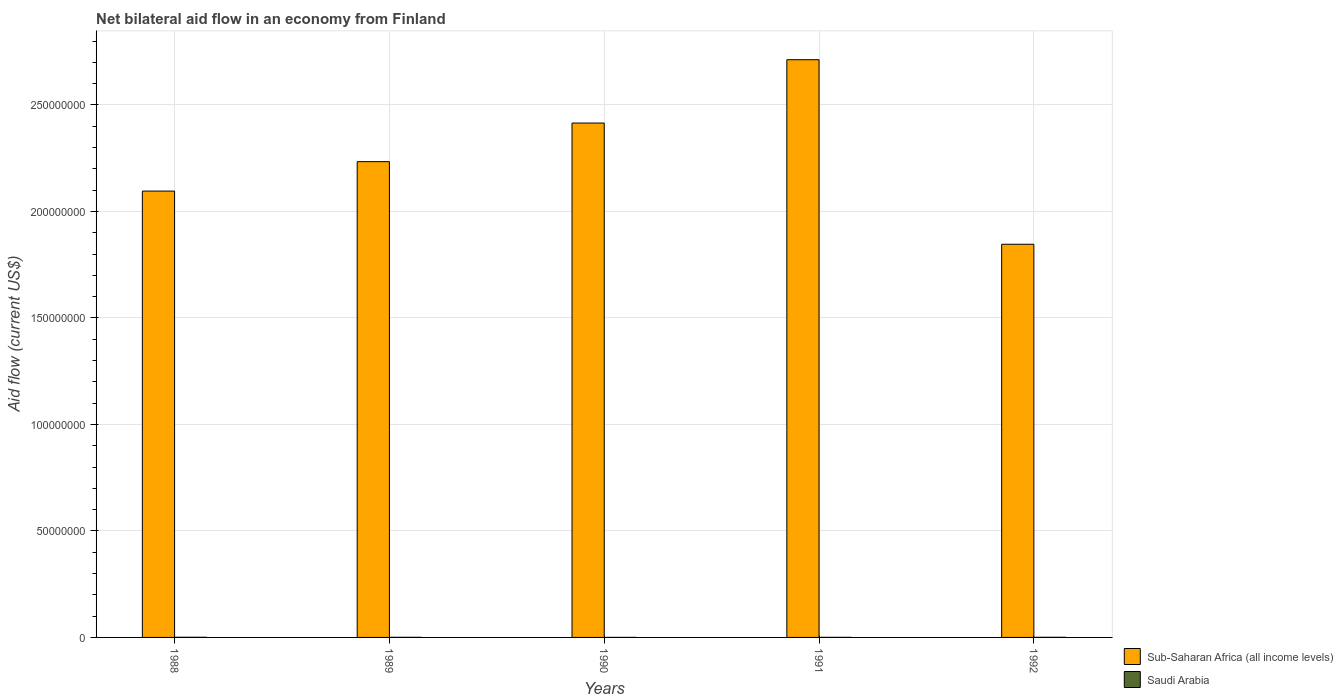How many different coloured bars are there?
Offer a terse response. 2. How many groups of bars are there?
Provide a succinct answer. 5. Are the number of bars on each tick of the X-axis equal?
Provide a short and direct response. Yes. How many bars are there on the 3rd tick from the left?
Your response must be concise. 2. How many bars are there on the 2nd tick from the right?
Keep it short and to the point. 2. What is the label of the 4th group of bars from the left?
Provide a succinct answer. 1991. In how many cases, is the number of bars for a given year not equal to the number of legend labels?
Your answer should be compact. 0. What is the net bilateral aid flow in Sub-Saharan Africa (all income levels) in 1988?
Offer a very short reply. 2.10e+08. Across all years, what is the maximum net bilateral aid flow in Sub-Saharan Africa (all income levels)?
Make the answer very short. 2.71e+08. Across all years, what is the minimum net bilateral aid flow in Sub-Saharan Africa (all income levels)?
Provide a succinct answer. 1.85e+08. What is the total net bilateral aid flow in Saudi Arabia in the graph?
Offer a terse response. 2.40e+05. What is the difference between the net bilateral aid flow in Sub-Saharan Africa (all income levels) in 1988 and that in 1990?
Your answer should be compact. -3.20e+07. What is the difference between the net bilateral aid flow in Saudi Arabia in 1991 and the net bilateral aid flow in Sub-Saharan Africa (all income levels) in 1990?
Your answer should be very brief. -2.41e+08. What is the average net bilateral aid flow in Sub-Saharan Africa (all income levels) per year?
Give a very brief answer. 2.26e+08. In the year 1992, what is the difference between the net bilateral aid flow in Saudi Arabia and net bilateral aid flow in Sub-Saharan Africa (all income levels)?
Give a very brief answer. -1.85e+08. In how many years, is the net bilateral aid flow in Saudi Arabia greater than 240000000 US$?
Make the answer very short. 0. What is the ratio of the net bilateral aid flow in Saudi Arabia in 1989 to that in 1992?
Your answer should be compact. 0.83. What is the difference between the highest and the second highest net bilateral aid flow in Sub-Saharan Africa (all income levels)?
Provide a succinct answer. 2.97e+07. In how many years, is the net bilateral aid flow in Sub-Saharan Africa (all income levels) greater than the average net bilateral aid flow in Sub-Saharan Africa (all income levels) taken over all years?
Give a very brief answer. 2. Is the sum of the net bilateral aid flow in Saudi Arabia in 1989 and 1990 greater than the maximum net bilateral aid flow in Sub-Saharan Africa (all income levels) across all years?
Your response must be concise. No. What does the 1st bar from the left in 1992 represents?
Your response must be concise. Sub-Saharan Africa (all income levels). What does the 2nd bar from the right in 1992 represents?
Keep it short and to the point. Sub-Saharan Africa (all income levels). How many years are there in the graph?
Offer a terse response. 5. What is the difference between two consecutive major ticks on the Y-axis?
Ensure brevity in your answer.  5.00e+07. Are the values on the major ticks of Y-axis written in scientific E-notation?
Your response must be concise. No. Does the graph contain any zero values?
Provide a short and direct response. No. Does the graph contain grids?
Make the answer very short. Yes. How many legend labels are there?
Your response must be concise. 2. How are the legend labels stacked?
Your answer should be very brief. Vertical. What is the title of the graph?
Your answer should be very brief. Net bilateral aid flow in an economy from Finland. Does "Least developed countries" appear as one of the legend labels in the graph?
Offer a terse response. No. What is the label or title of the X-axis?
Your response must be concise. Years. What is the Aid flow (current US$) of Sub-Saharan Africa (all income levels) in 1988?
Ensure brevity in your answer.  2.10e+08. What is the Aid flow (current US$) of Saudi Arabia in 1988?
Offer a terse response. 7.00e+04. What is the Aid flow (current US$) of Sub-Saharan Africa (all income levels) in 1989?
Provide a succinct answer. 2.23e+08. What is the Aid flow (current US$) of Saudi Arabia in 1989?
Your response must be concise. 5.00e+04. What is the Aid flow (current US$) in Sub-Saharan Africa (all income levels) in 1990?
Keep it short and to the point. 2.41e+08. What is the Aid flow (current US$) of Saudi Arabia in 1990?
Give a very brief answer. 2.00e+04. What is the Aid flow (current US$) in Sub-Saharan Africa (all income levels) in 1991?
Your response must be concise. 2.71e+08. What is the Aid flow (current US$) of Saudi Arabia in 1991?
Offer a very short reply. 4.00e+04. What is the Aid flow (current US$) in Sub-Saharan Africa (all income levels) in 1992?
Ensure brevity in your answer.  1.85e+08. What is the Aid flow (current US$) of Saudi Arabia in 1992?
Keep it short and to the point. 6.00e+04. Across all years, what is the maximum Aid flow (current US$) of Sub-Saharan Africa (all income levels)?
Offer a very short reply. 2.71e+08. Across all years, what is the minimum Aid flow (current US$) in Sub-Saharan Africa (all income levels)?
Ensure brevity in your answer.  1.85e+08. Across all years, what is the minimum Aid flow (current US$) in Saudi Arabia?
Give a very brief answer. 2.00e+04. What is the total Aid flow (current US$) in Sub-Saharan Africa (all income levels) in the graph?
Your answer should be very brief. 1.13e+09. What is the total Aid flow (current US$) of Saudi Arabia in the graph?
Your answer should be very brief. 2.40e+05. What is the difference between the Aid flow (current US$) in Sub-Saharan Africa (all income levels) in 1988 and that in 1989?
Your response must be concise. -1.38e+07. What is the difference between the Aid flow (current US$) of Saudi Arabia in 1988 and that in 1989?
Your response must be concise. 2.00e+04. What is the difference between the Aid flow (current US$) of Sub-Saharan Africa (all income levels) in 1988 and that in 1990?
Provide a short and direct response. -3.20e+07. What is the difference between the Aid flow (current US$) in Sub-Saharan Africa (all income levels) in 1988 and that in 1991?
Keep it short and to the point. -6.17e+07. What is the difference between the Aid flow (current US$) in Sub-Saharan Africa (all income levels) in 1988 and that in 1992?
Your answer should be very brief. 2.50e+07. What is the difference between the Aid flow (current US$) of Saudi Arabia in 1988 and that in 1992?
Offer a very short reply. 10000. What is the difference between the Aid flow (current US$) in Sub-Saharan Africa (all income levels) in 1989 and that in 1990?
Offer a very short reply. -1.81e+07. What is the difference between the Aid flow (current US$) of Saudi Arabia in 1989 and that in 1990?
Offer a very short reply. 3.00e+04. What is the difference between the Aid flow (current US$) of Sub-Saharan Africa (all income levels) in 1989 and that in 1991?
Ensure brevity in your answer.  -4.79e+07. What is the difference between the Aid flow (current US$) in Saudi Arabia in 1989 and that in 1991?
Your answer should be very brief. 10000. What is the difference between the Aid flow (current US$) of Sub-Saharan Africa (all income levels) in 1989 and that in 1992?
Ensure brevity in your answer.  3.88e+07. What is the difference between the Aid flow (current US$) in Sub-Saharan Africa (all income levels) in 1990 and that in 1991?
Offer a terse response. -2.97e+07. What is the difference between the Aid flow (current US$) of Sub-Saharan Africa (all income levels) in 1990 and that in 1992?
Keep it short and to the point. 5.69e+07. What is the difference between the Aid flow (current US$) in Sub-Saharan Africa (all income levels) in 1991 and that in 1992?
Provide a short and direct response. 8.66e+07. What is the difference between the Aid flow (current US$) of Saudi Arabia in 1991 and that in 1992?
Your response must be concise. -2.00e+04. What is the difference between the Aid flow (current US$) of Sub-Saharan Africa (all income levels) in 1988 and the Aid flow (current US$) of Saudi Arabia in 1989?
Ensure brevity in your answer.  2.09e+08. What is the difference between the Aid flow (current US$) of Sub-Saharan Africa (all income levels) in 1988 and the Aid flow (current US$) of Saudi Arabia in 1990?
Your response must be concise. 2.10e+08. What is the difference between the Aid flow (current US$) in Sub-Saharan Africa (all income levels) in 1988 and the Aid flow (current US$) in Saudi Arabia in 1991?
Make the answer very short. 2.10e+08. What is the difference between the Aid flow (current US$) of Sub-Saharan Africa (all income levels) in 1988 and the Aid flow (current US$) of Saudi Arabia in 1992?
Make the answer very short. 2.09e+08. What is the difference between the Aid flow (current US$) in Sub-Saharan Africa (all income levels) in 1989 and the Aid flow (current US$) in Saudi Arabia in 1990?
Keep it short and to the point. 2.23e+08. What is the difference between the Aid flow (current US$) in Sub-Saharan Africa (all income levels) in 1989 and the Aid flow (current US$) in Saudi Arabia in 1991?
Your answer should be very brief. 2.23e+08. What is the difference between the Aid flow (current US$) of Sub-Saharan Africa (all income levels) in 1989 and the Aid flow (current US$) of Saudi Arabia in 1992?
Your answer should be very brief. 2.23e+08. What is the difference between the Aid flow (current US$) of Sub-Saharan Africa (all income levels) in 1990 and the Aid flow (current US$) of Saudi Arabia in 1991?
Your response must be concise. 2.41e+08. What is the difference between the Aid flow (current US$) of Sub-Saharan Africa (all income levels) in 1990 and the Aid flow (current US$) of Saudi Arabia in 1992?
Your answer should be compact. 2.41e+08. What is the difference between the Aid flow (current US$) in Sub-Saharan Africa (all income levels) in 1991 and the Aid flow (current US$) in Saudi Arabia in 1992?
Provide a short and direct response. 2.71e+08. What is the average Aid flow (current US$) in Sub-Saharan Africa (all income levels) per year?
Your response must be concise. 2.26e+08. What is the average Aid flow (current US$) in Saudi Arabia per year?
Your answer should be very brief. 4.80e+04. In the year 1988, what is the difference between the Aid flow (current US$) in Sub-Saharan Africa (all income levels) and Aid flow (current US$) in Saudi Arabia?
Your response must be concise. 2.09e+08. In the year 1989, what is the difference between the Aid flow (current US$) in Sub-Saharan Africa (all income levels) and Aid flow (current US$) in Saudi Arabia?
Your answer should be compact. 2.23e+08. In the year 1990, what is the difference between the Aid flow (current US$) of Sub-Saharan Africa (all income levels) and Aid flow (current US$) of Saudi Arabia?
Keep it short and to the point. 2.41e+08. In the year 1991, what is the difference between the Aid flow (current US$) of Sub-Saharan Africa (all income levels) and Aid flow (current US$) of Saudi Arabia?
Ensure brevity in your answer.  2.71e+08. In the year 1992, what is the difference between the Aid flow (current US$) of Sub-Saharan Africa (all income levels) and Aid flow (current US$) of Saudi Arabia?
Your response must be concise. 1.85e+08. What is the ratio of the Aid flow (current US$) of Sub-Saharan Africa (all income levels) in 1988 to that in 1989?
Ensure brevity in your answer.  0.94. What is the ratio of the Aid flow (current US$) of Saudi Arabia in 1988 to that in 1989?
Your answer should be very brief. 1.4. What is the ratio of the Aid flow (current US$) of Sub-Saharan Africa (all income levels) in 1988 to that in 1990?
Provide a short and direct response. 0.87. What is the ratio of the Aid flow (current US$) of Saudi Arabia in 1988 to that in 1990?
Offer a terse response. 3.5. What is the ratio of the Aid flow (current US$) of Sub-Saharan Africa (all income levels) in 1988 to that in 1991?
Offer a terse response. 0.77. What is the ratio of the Aid flow (current US$) in Sub-Saharan Africa (all income levels) in 1988 to that in 1992?
Give a very brief answer. 1.14. What is the ratio of the Aid flow (current US$) in Saudi Arabia in 1988 to that in 1992?
Offer a terse response. 1.17. What is the ratio of the Aid flow (current US$) of Sub-Saharan Africa (all income levels) in 1989 to that in 1990?
Provide a short and direct response. 0.92. What is the ratio of the Aid flow (current US$) of Saudi Arabia in 1989 to that in 1990?
Offer a very short reply. 2.5. What is the ratio of the Aid flow (current US$) of Sub-Saharan Africa (all income levels) in 1989 to that in 1991?
Provide a succinct answer. 0.82. What is the ratio of the Aid flow (current US$) of Saudi Arabia in 1989 to that in 1991?
Provide a short and direct response. 1.25. What is the ratio of the Aid flow (current US$) of Sub-Saharan Africa (all income levels) in 1989 to that in 1992?
Your response must be concise. 1.21. What is the ratio of the Aid flow (current US$) of Saudi Arabia in 1989 to that in 1992?
Ensure brevity in your answer.  0.83. What is the ratio of the Aid flow (current US$) in Sub-Saharan Africa (all income levels) in 1990 to that in 1991?
Offer a terse response. 0.89. What is the ratio of the Aid flow (current US$) of Saudi Arabia in 1990 to that in 1991?
Provide a succinct answer. 0.5. What is the ratio of the Aid flow (current US$) in Sub-Saharan Africa (all income levels) in 1990 to that in 1992?
Your response must be concise. 1.31. What is the ratio of the Aid flow (current US$) of Sub-Saharan Africa (all income levels) in 1991 to that in 1992?
Make the answer very short. 1.47. What is the difference between the highest and the second highest Aid flow (current US$) in Sub-Saharan Africa (all income levels)?
Provide a short and direct response. 2.97e+07. What is the difference between the highest and the second highest Aid flow (current US$) in Saudi Arabia?
Provide a short and direct response. 10000. What is the difference between the highest and the lowest Aid flow (current US$) in Sub-Saharan Africa (all income levels)?
Give a very brief answer. 8.66e+07. 